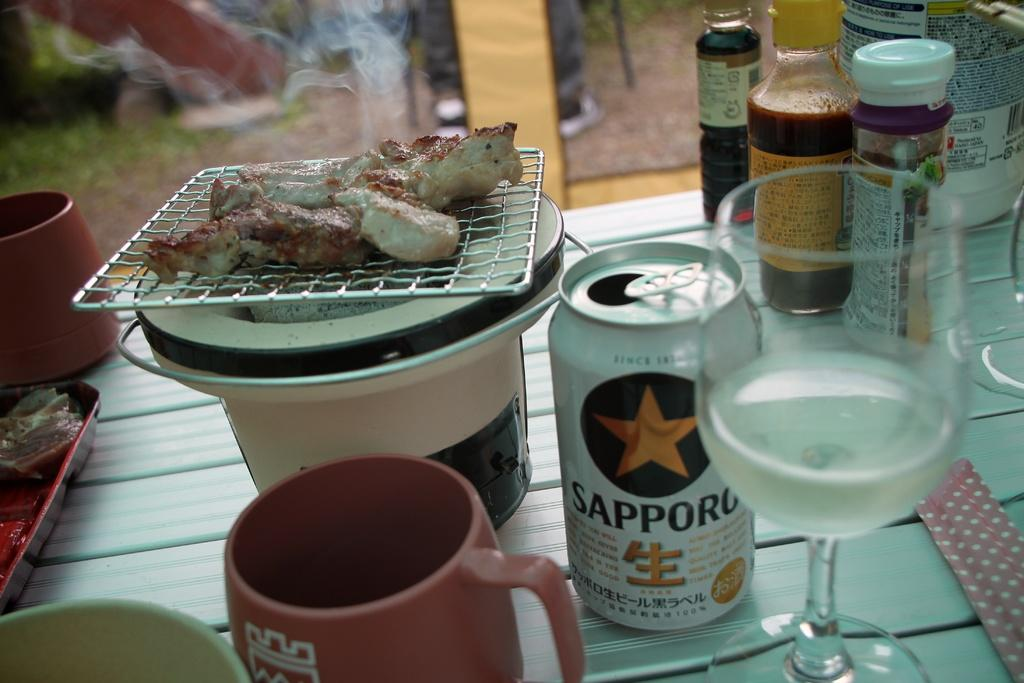<image>
Render a clear and concise summary of the photo. A tin of Sapporo been sits in the middle of a cluttered table. 